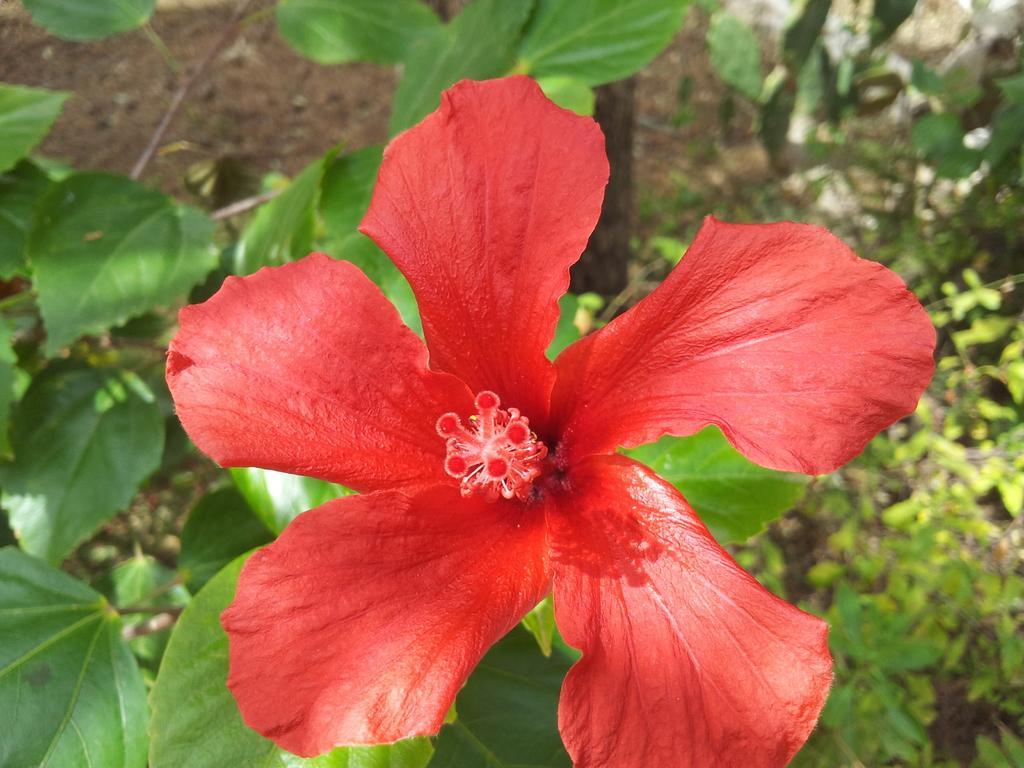Please provide a concise description of this image. In this image, we can see some plants. We can see a flower on one of the plants. 